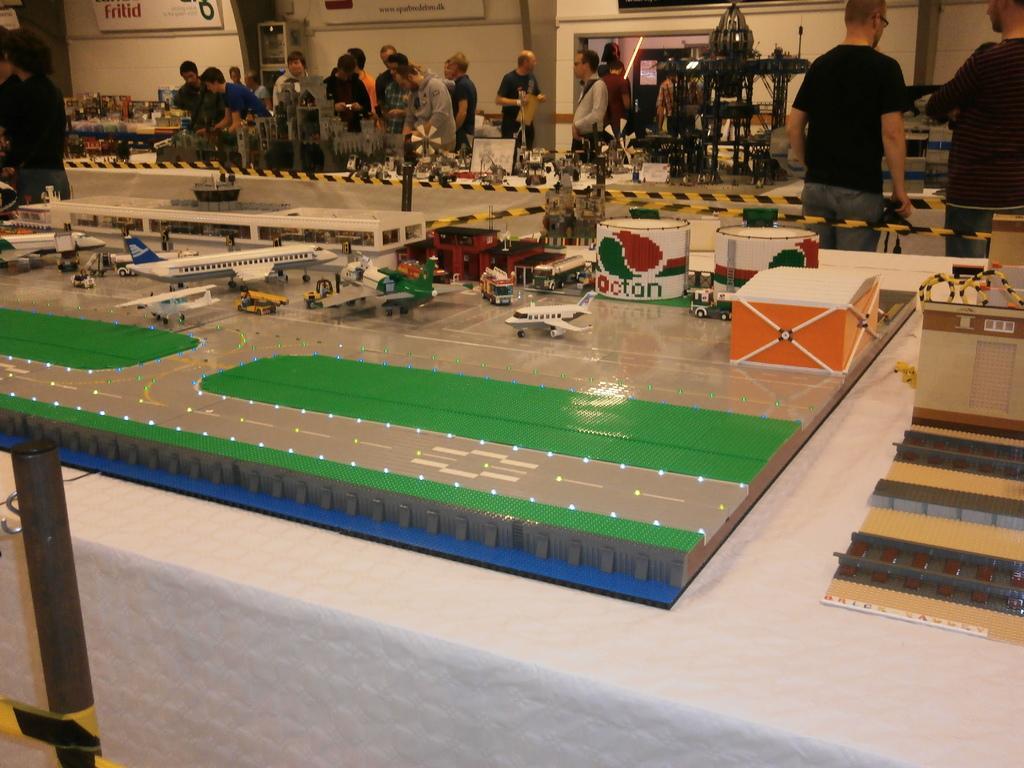Please provide a concise description of this image. In the image we can see there are people standing and wearing clothes. Here we can see toys of flying jets and boxes. Here we can see yellow tape, pole, poster and the wall. 